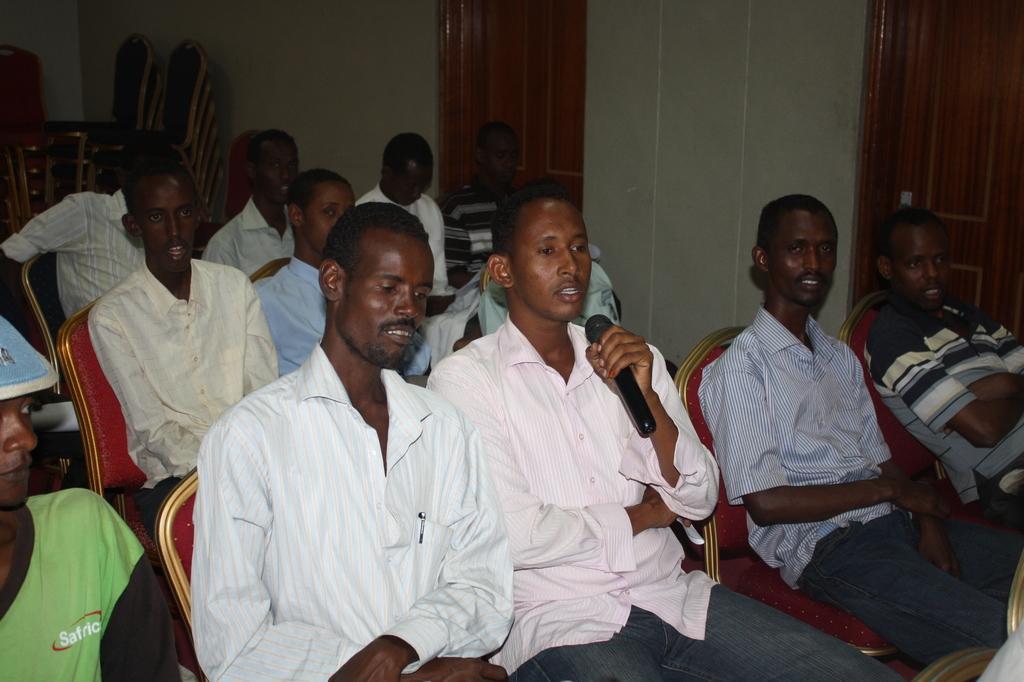Can you describe this image briefly? In this image we can see people are sitting on the chairs and there is a person holding a mike with his hand. In the background we can see wall, doors, and chairs. 